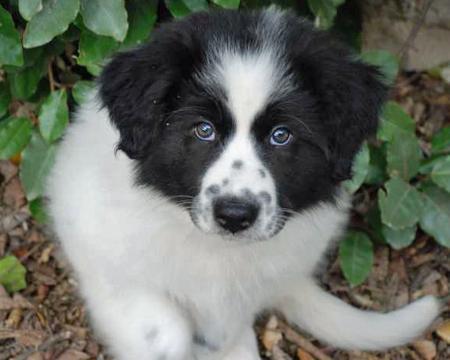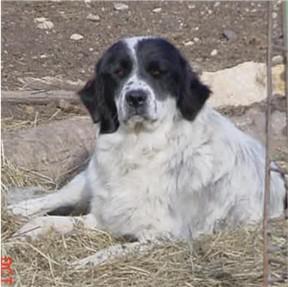The first image is the image on the left, the second image is the image on the right. Analyze the images presented: Is the assertion "there is a person near a dog in the image on the right side." valid? Answer yes or no. No. The first image is the image on the left, the second image is the image on the right. Evaluate the accuracy of this statement regarding the images: "On of the images contains a young girl in a green sweater with a large white dog.". Is it true? Answer yes or no. No. 